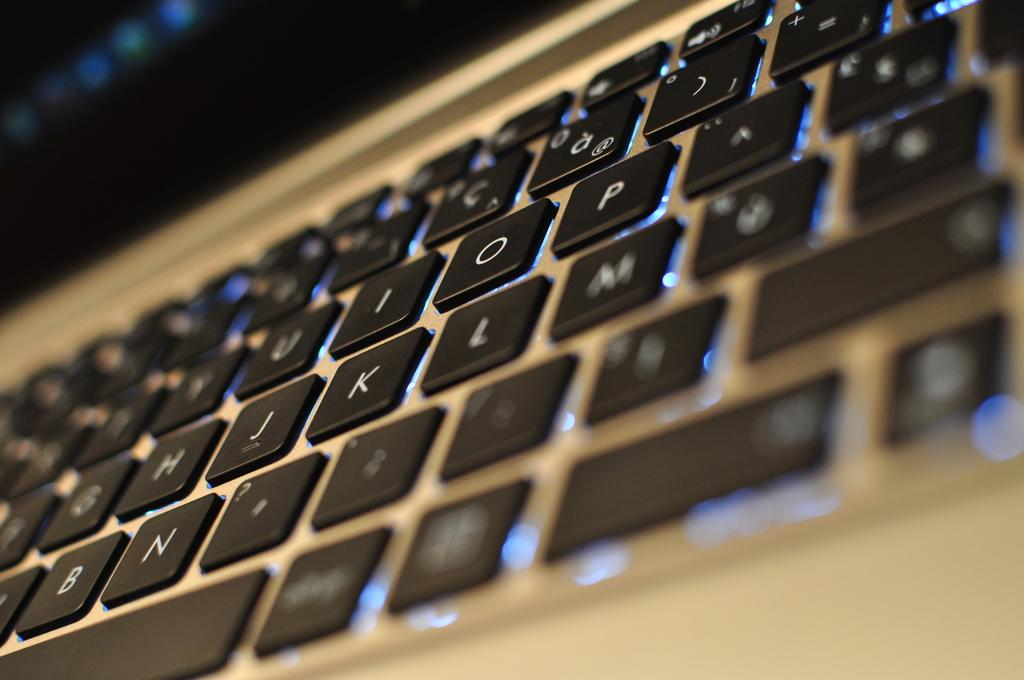<image>
Write a terse but informative summary of the picture. A lighted keyboard has the H, J, K and L keys visible. 